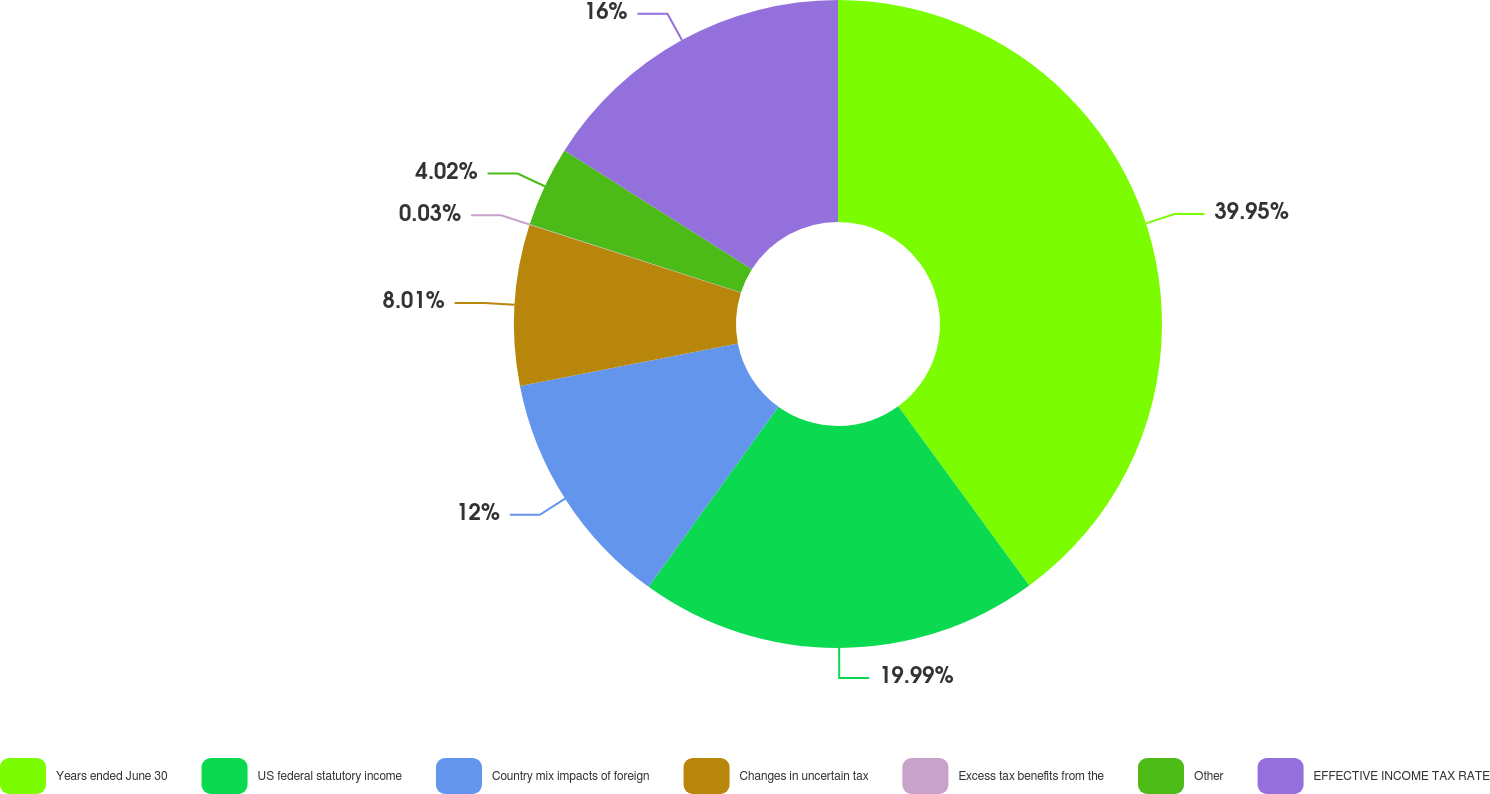Convert chart. <chart><loc_0><loc_0><loc_500><loc_500><pie_chart><fcel>Years ended June 30<fcel>US federal statutory income<fcel>Country mix impacts of foreign<fcel>Changes in uncertain tax<fcel>Excess tax benefits from the<fcel>Other<fcel>EFFECTIVE INCOME TAX RATE<nl><fcel>39.95%<fcel>19.99%<fcel>12.0%<fcel>8.01%<fcel>0.03%<fcel>4.02%<fcel>16.0%<nl></chart> 